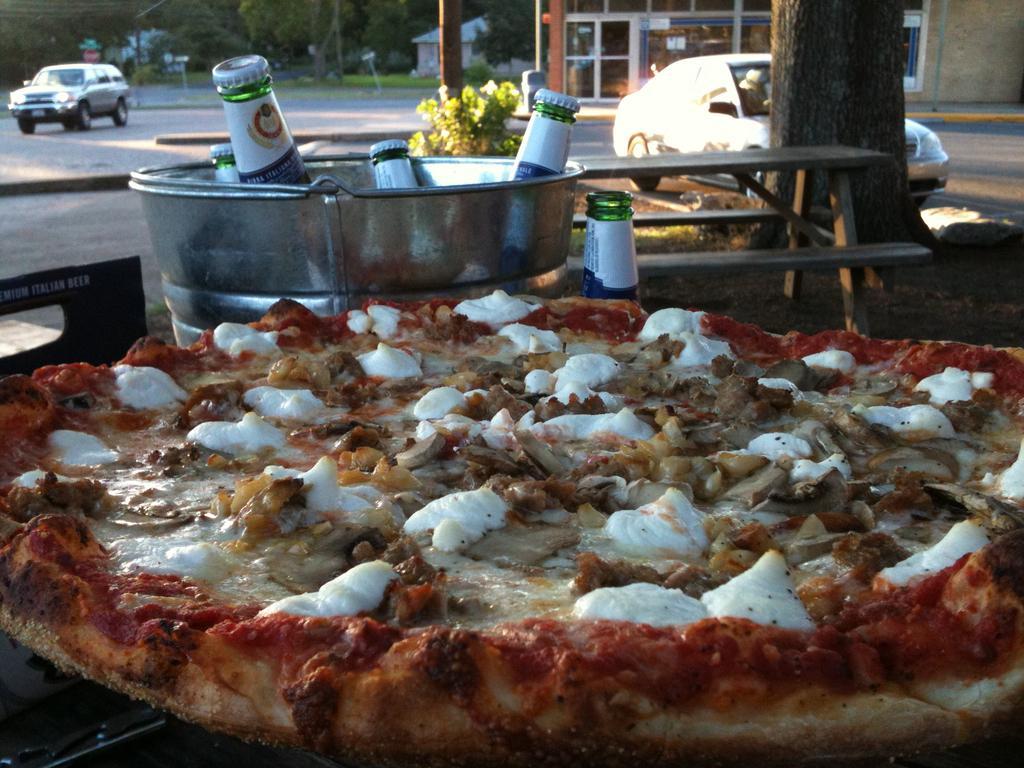In one or two sentences, can you explain what this image depicts? In this image i can see a pizza at the back ground i can see few bottles in a bucket, car, a building and a tree. 